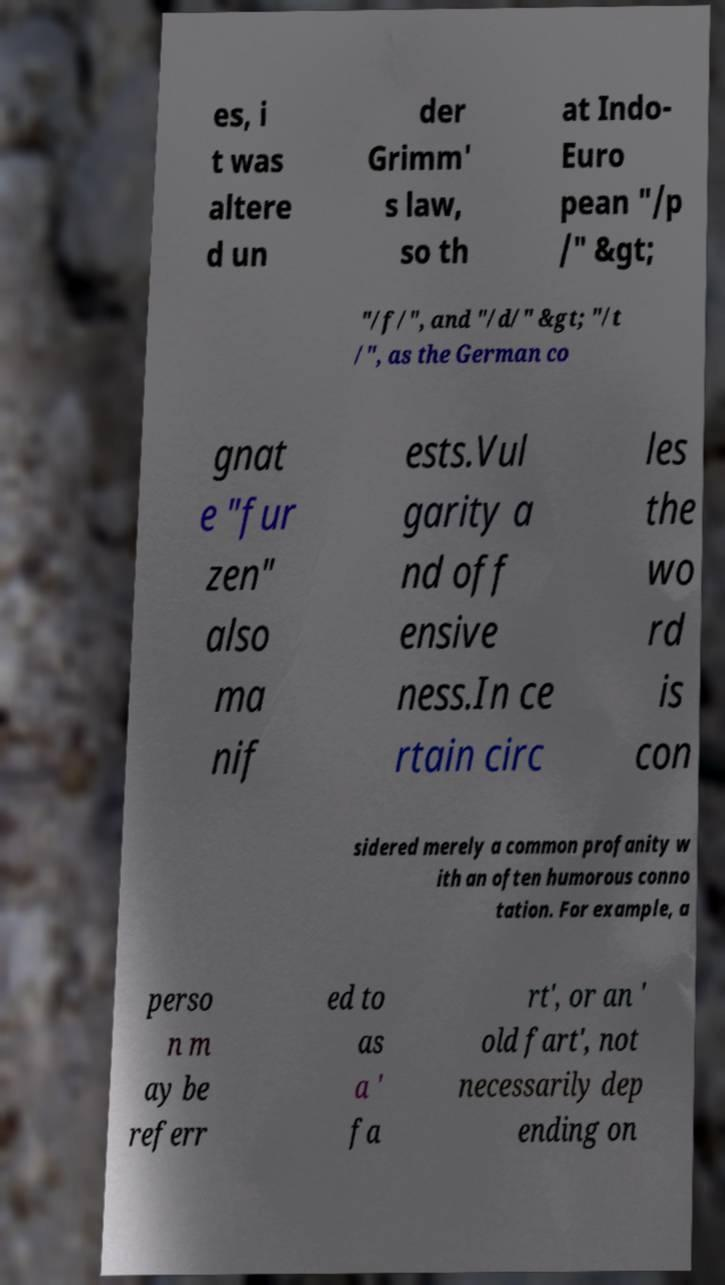Could you extract and type out the text from this image? es, i t was altere d un der Grimm' s law, so th at Indo- Euro pean "/p /" &gt; "/f/", and "/d/" &gt; "/t /", as the German co gnat e "fur zen" also ma nif ests.Vul garity a nd off ensive ness.In ce rtain circ les the wo rd is con sidered merely a common profanity w ith an often humorous conno tation. For example, a perso n m ay be referr ed to as a ' fa rt', or an ' old fart', not necessarily dep ending on 